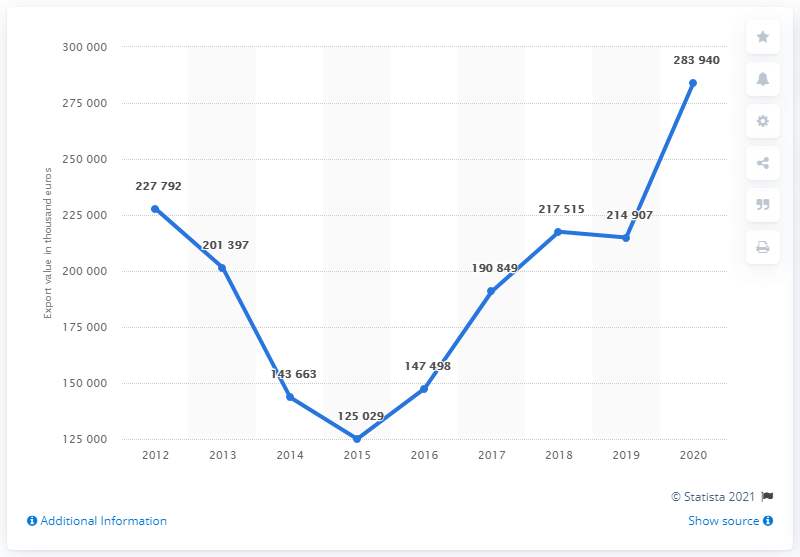List a handful of essential elements in this visual. What is the difference between the years 2020 and 2019? 69033 has a greater value than 68033. In 2015, the value was the lowest among all the years. 